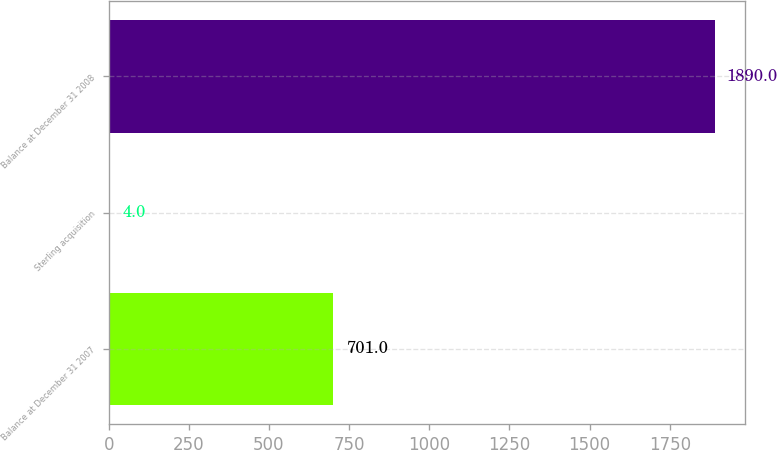<chart> <loc_0><loc_0><loc_500><loc_500><bar_chart><fcel>Balance at December 31 2007<fcel>Sterling acquisition<fcel>Balance at December 31 2008<nl><fcel>701<fcel>4<fcel>1890<nl></chart> 